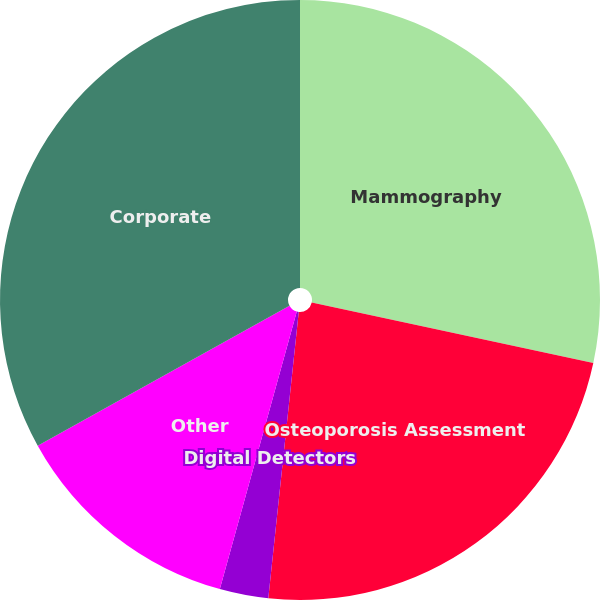Convert chart. <chart><loc_0><loc_0><loc_500><loc_500><pie_chart><fcel>Mammography<fcel>Osteoporosis Assessment<fcel>Digital Detectors<fcel>Other<fcel>Corporate<nl><fcel>28.37%<fcel>23.32%<fcel>2.62%<fcel>12.63%<fcel>33.07%<nl></chart> 